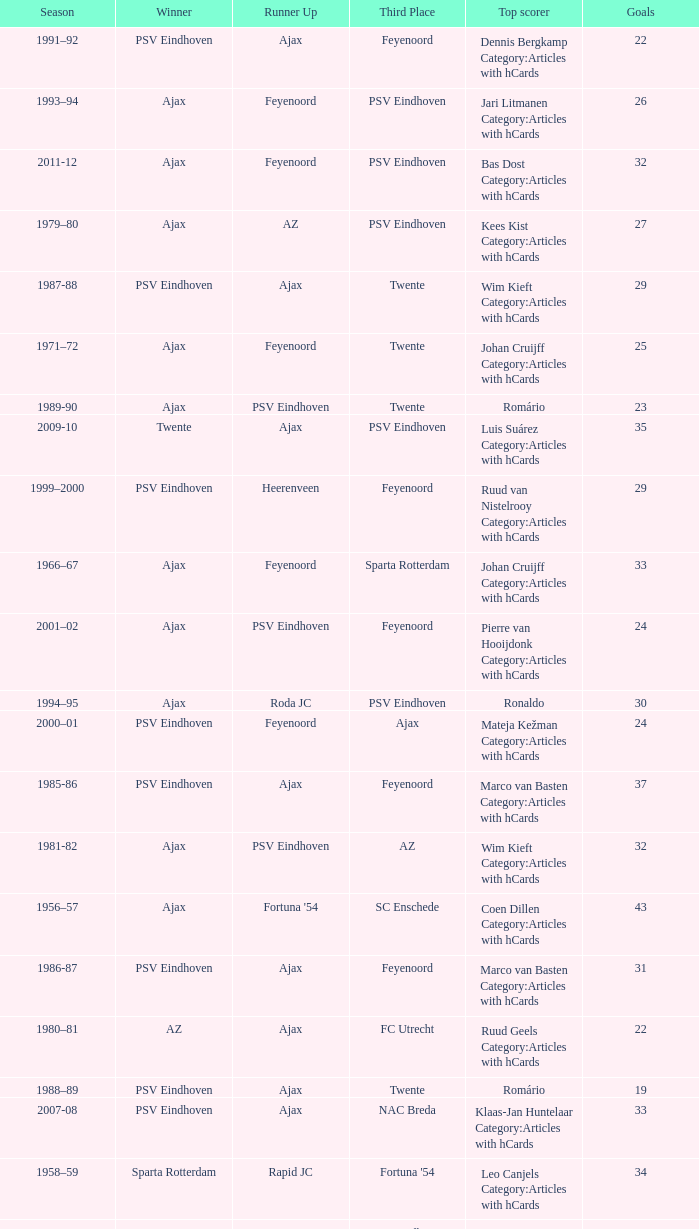When twente came in third place and ajax was the winner what are the seasons? 1971–72, 1989-90. 